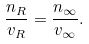<formula> <loc_0><loc_0><loc_500><loc_500>\frac { n _ { R } } { v _ { R } } = \frac { n _ { \infty } } { v _ { \infty } } .</formula> 